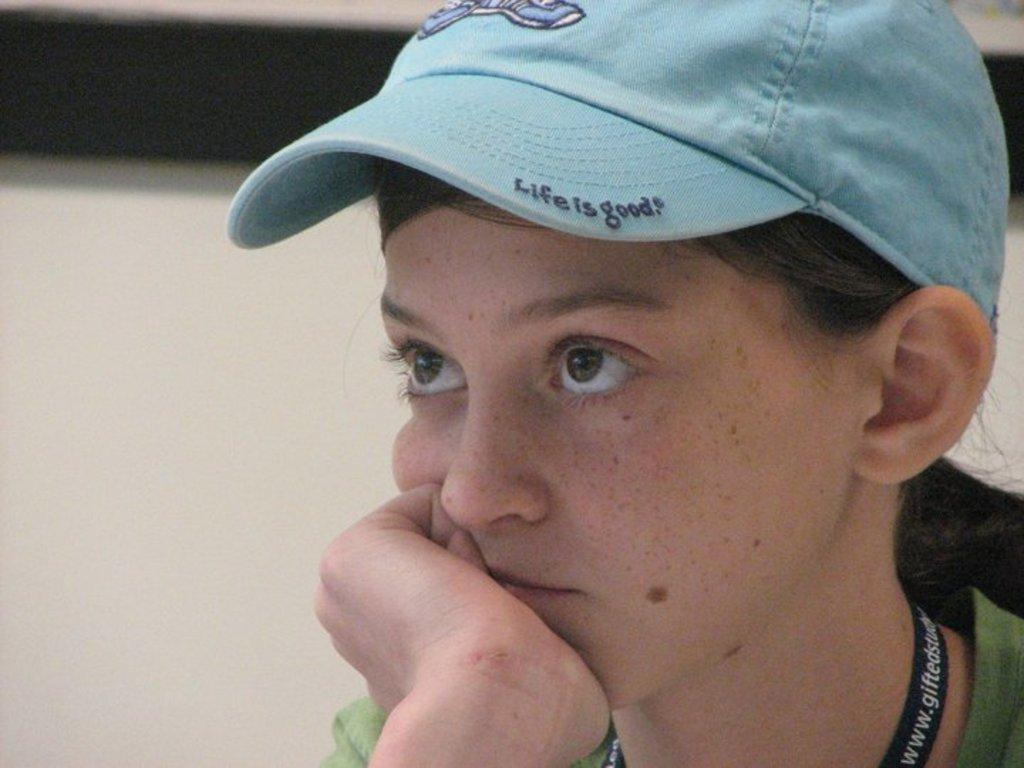What is present in the image? There is a person in the image. Can you describe the person's attire? The person is wearing a cap. What color is the cap? The cap is blue in color. Is there any text on the cap? Yes, there is text written on the cap. What story does the person in the image tell with their pocket? There is no mention of a story or a pocket in the image, so this question cannot be answered definitively. 